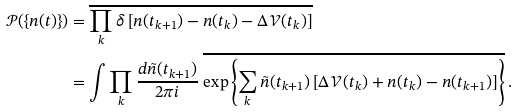Convert formula to latex. <formula><loc_0><loc_0><loc_500><loc_500>\mathcal { P } ( \{ n ( t ) \} ) & = \overline { \prod _ { k } \delta \left [ n ( t _ { k + 1 } ) - n ( t _ { k } ) - \Delta \mathcal { V } ( t _ { k } ) \right ] } \\ & = \int \prod _ { k } \frac { d \tilde { n } ( t _ { k + 1 } ) } { 2 \pi i } \ \overline { \exp \left \{ \sum _ { k } \tilde { n } ( t _ { k + 1 } ) \left [ \Delta \mathcal { V } ( t _ { k } ) + n ( t _ { k } ) - n ( t _ { k + 1 } ) \right ] \right \} } \, .</formula> 